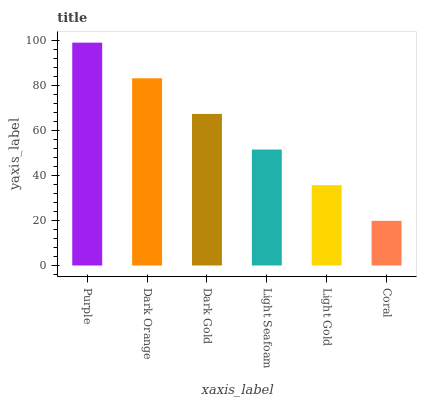Is Coral the minimum?
Answer yes or no. Yes. Is Purple the maximum?
Answer yes or no. Yes. Is Dark Orange the minimum?
Answer yes or no. No. Is Dark Orange the maximum?
Answer yes or no. No. Is Purple greater than Dark Orange?
Answer yes or no. Yes. Is Dark Orange less than Purple?
Answer yes or no. Yes. Is Dark Orange greater than Purple?
Answer yes or no. No. Is Purple less than Dark Orange?
Answer yes or no. No. Is Dark Gold the high median?
Answer yes or no. Yes. Is Light Seafoam the low median?
Answer yes or no. Yes. Is Purple the high median?
Answer yes or no. No. Is Purple the low median?
Answer yes or no. No. 